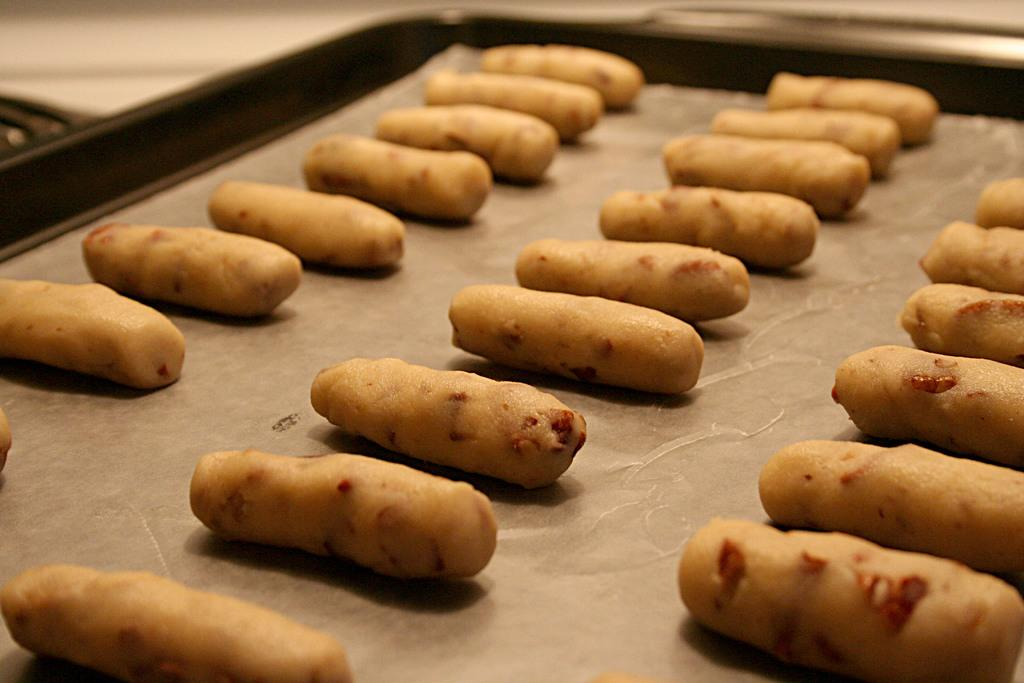What object is present in the image that can hold items? There is a tray in the image that can hold items. What is covering the surface of the tray? The tray contains white paper. What type of food or edible items can be seen on the tray? There are snacks on the tray. What type of frame is visible around the snacks on the tray? There is no frame visible around the snacks on the tray; the image only shows the tray, white paper, and snacks. 